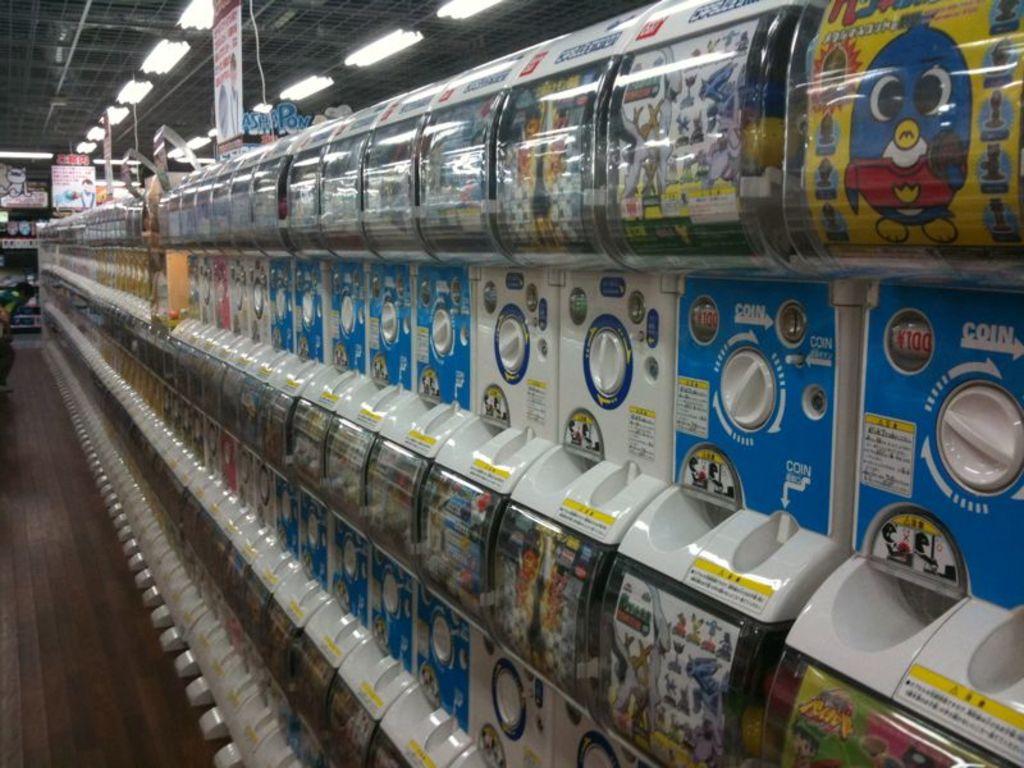Are these to machines to put coins in and out come different kinds of stickers?
Your answer should be compact. Answering does not require reading text in the image. 